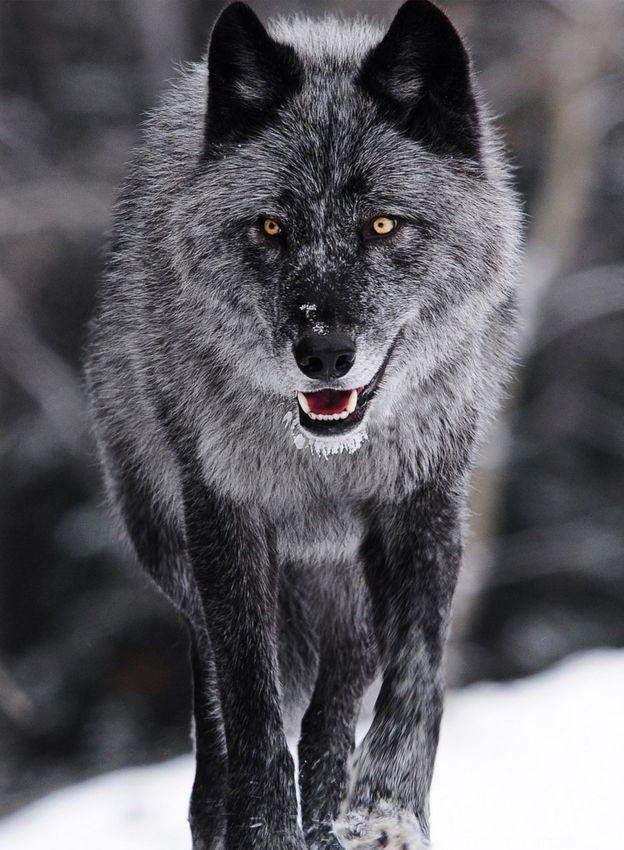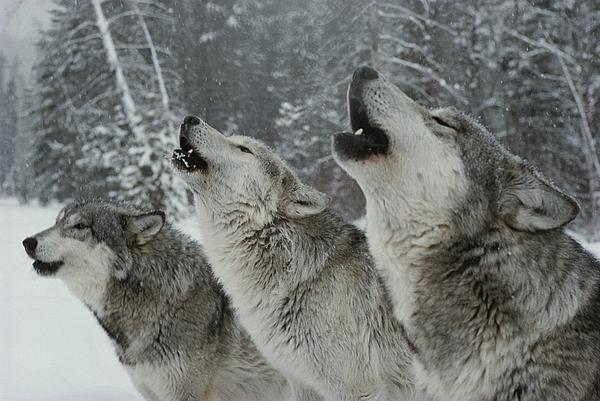The first image is the image on the left, the second image is the image on the right. Analyze the images presented: Is the assertion "The left image contains at least two wolves." valid? Answer yes or no. No. The first image is the image on the left, the second image is the image on the right. Evaluate the accuracy of this statement regarding the images: "At least one of the wolves is looking straight at the camera.". Is it true? Answer yes or no. Yes. 